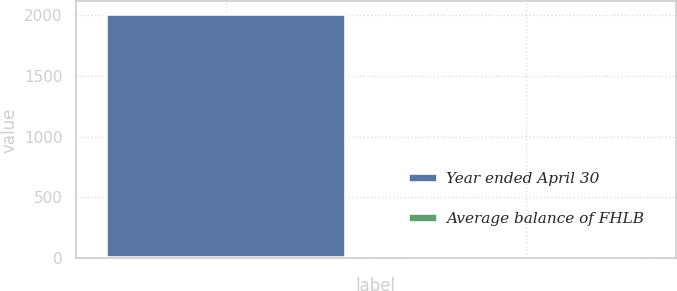<chart> <loc_0><loc_0><loc_500><loc_500><bar_chart><fcel>Year ended April 30<fcel>Average balance of FHLB<nl><fcel>2010<fcel>2.07<nl></chart> 